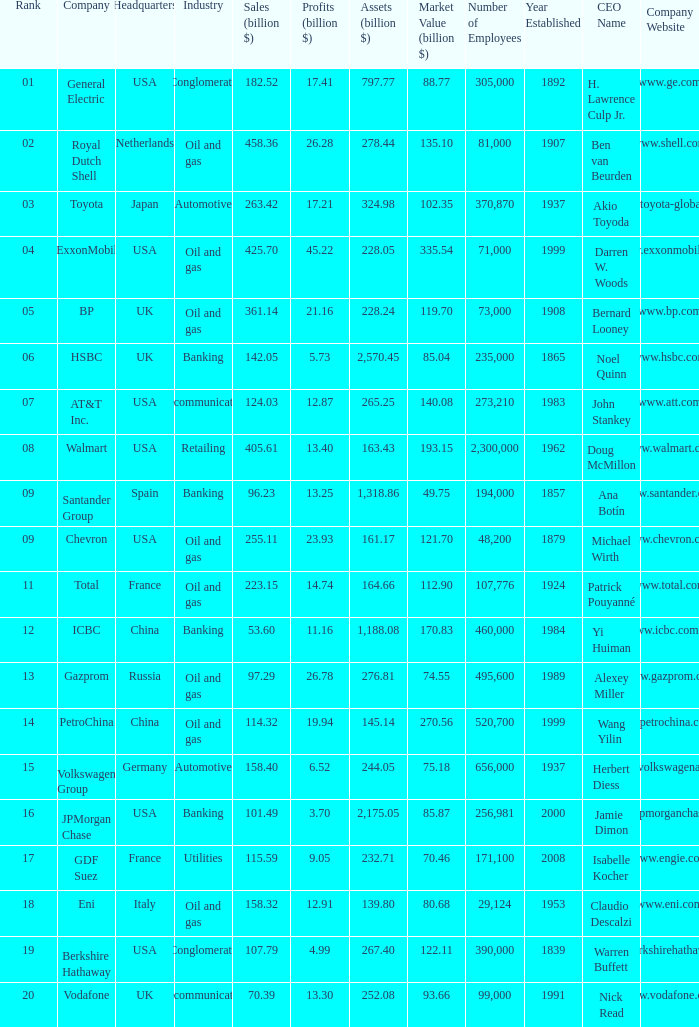Would you be able to parse every entry in this table? {'header': ['Rank', 'Company', 'Headquarters', 'Industry', 'Sales (billion $)', 'Profits (billion $)', 'Assets (billion $)', 'Market Value (billion $)', 'Number of Employees', 'Year Established', 'CEO Name', 'Company Website'], 'rows': [['01', 'General Electric', 'USA', 'Conglomerate', '182.52', '17.41', '797.77', '88.77', '305,000', '1892', 'H. Lawrence Culp Jr.', 'www.ge.com'], ['02', 'Royal Dutch Shell', 'Netherlands', 'Oil and gas', '458.36', '26.28', '278.44', '135.10', '81,000', '1907', 'Ben van Beurden', 'www.shell.com'], ['03', 'Toyota', 'Japan', 'Automotive', '263.42', '17.21', '324.98', '102.35', '370,870', '1937', 'Akio Toyoda', 'www.toyota-global.com'], ['04', 'ExxonMobil', 'USA', 'Oil and gas', '425.70', '45.22', '228.05', '335.54', '71,000', '1999', 'Darren W. Woods', 'www.exxonmobil.com'], ['05', 'BP', 'UK', 'Oil and gas', '361.14', '21.16', '228.24', '119.70', '73,000', '1908', 'Bernard Looney', 'www.bp.com'], ['06', 'HSBC', 'UK', 'Banking', '142.05', '5.73', '2,570.45', '85.04', '235,000', '1865', 'Noel Quinn', 'www.hsbc.com'], ['07', 'AT&T Inc.', 'USA', 'Telecommunications', '124.03', '12.87', '265.25', '140.08', '273,210', '1983', 'John Stankey', 'www.att.com'], ['08', 'Walmart', 'USA', 'Retailing', '405.61', '13.40', '163.43', '193.15', '2,300,000', '1962', 'Doug McMillon', 'www.walmart.com'], ['09', 'Santander Group', 'Spain', 'Banking', '96.23', '13.25', '1,318.86', '49.75', '194,000', '1857', 'Ana Botín', 'www.santander.com'], ['09', 'Chevron', 'USA', 'Oil and gas', '255.11', '23.93', '161.17', '121.70', '48,200', '1879', 'Michael Wirth', 'www.chevron.com'], ['11', 'Total', 'France', 'Oil and gas', '223.15', '14.74', '164.66', '112.90', '107,776', '1924', 'Patrick Pouyanné', 'www.total.com'], ['12', 'ICBC', 'China', 'Banking', '53.60', '11.16', '1,188.08', '170.83', '460,000', '1984', 'Yi Huiman', 'www.icbc.com.cn'], ['13', 'Gazprom', 'Russia', 'Oil and gas', '97.29', '26.78', '276.81', '74.55', '495,600', '1989', 'Alexey Miller', 'www.gazprom.com'], ['14', 'PetroChina', 'China', 'Oil and gas', '114.32', '19.94', '145.14', '270.56', '520,700', '1999', 'Wang Yilin', 'www.petrochina.com.cn'], ['15', 'Volkswagen Group', 'Germany', 'Automotive', '158.40', '6.52', '244.05', '75.18', '656,000', '1937', 'Herbert Diess', 'www.volkswagenag.com'], ['16', 'JPMorgan Chase', 'USA', 'Banking', '101.49', '3.70', '2,175.05', '85.87', '256,981', '2000', 'Jamie Dimon', 'www.jpmorganchase.com'], ['17', 'GDF Suez', 'France', 'Utilities', '115.59', '9.05', '232.71', '70.46', '171,100', '2008', 'Isabelle Kocher', 'www.engie.com'], ['18', 'Eni', 'Italy', 'Oil and gas', '158.32', '12.91', '139.80', '80.68', '29,124', '1953', 'Claudio Descalzi', 'www.eni.com'], ['19', 'Berkshire Hathaway', 'USA', 'Conglomerate', '107.79', '4.99', '267.40', '122.11', '390,000', '1839', 'Warren Buffett', 'www.berkshirehathaway.com'], ['20', 'Vodafone', 'UK', 'Telecommunications', '70.39', '13.30', '252.08', '93.66', '99,000', '1991', 'Nick Read', 'www.vodafone.com']]} Name the lowest Profits (billion $) which has a Sales (billion $) of 425.7, and a Rank larger than 4? None. 